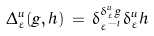<formula> <loc_0><loc_0><loc_500><loc_500>\Delta _ { \varepsilon } ^ { u } ( g , h ) \, = \, \delta _ { \varepsilon ^ { - 1 } } ^ { \delta _ { \varepsilon } ^ { u } g } \delta _ { \varepsilon } ^ { u } h</formula> 